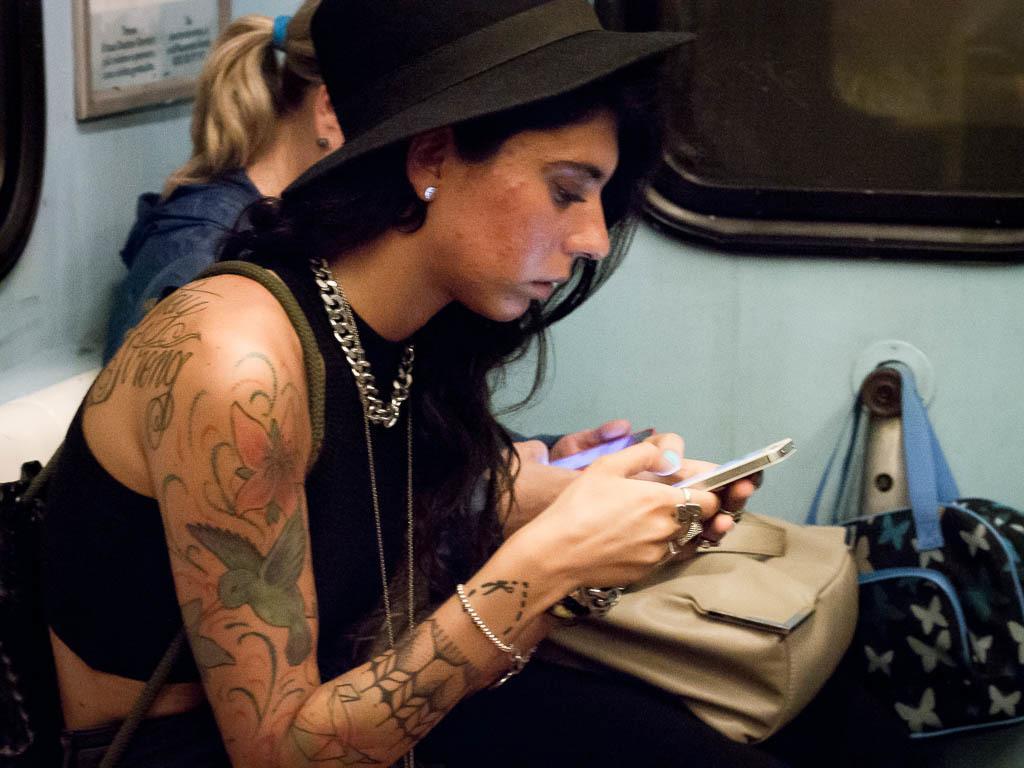In one or two sentences, can you explain what this image depicts? This is the picture taken in a room, there are two women's sitting on chair. The woman in black dress was holding a mobile and the other woman is also holding a mobile and a bag. Behind the people there is a glass window and a black bag. 